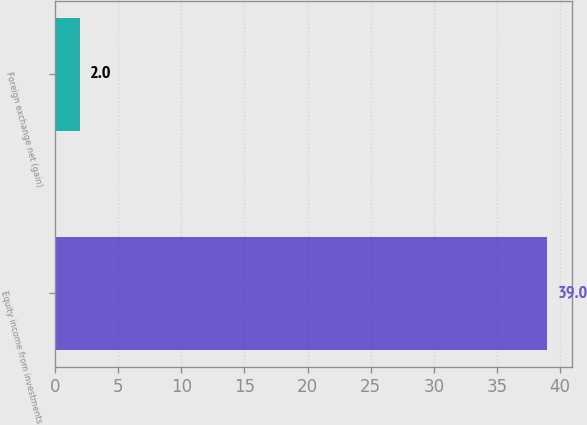Convert chart to OTSL. <chart><loc_0><loc_0><loc_500><loc_500><bar_chart><fcel>Equity income from investments<fcel>Foreign exchange net (gain)<nl><fcel>39<fcel>2<nl></chart> 